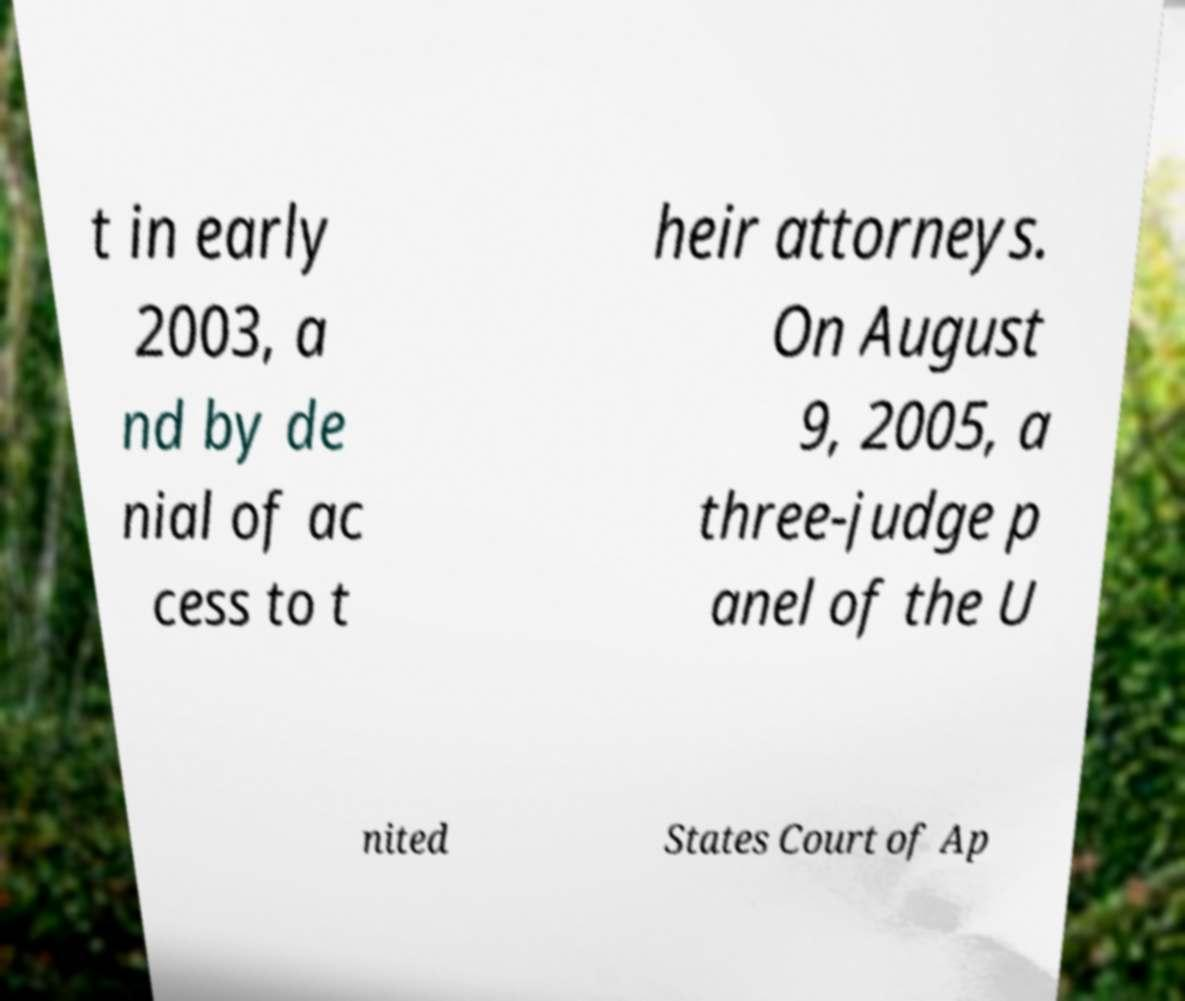Could you assist in decoding the text presented in this image and type it out clearly? t in early 2003, a nd by de nial of ac cess to t heir attorneys. On August 9, 2005, a three-judge p anel of the U nited States Court of Ap 